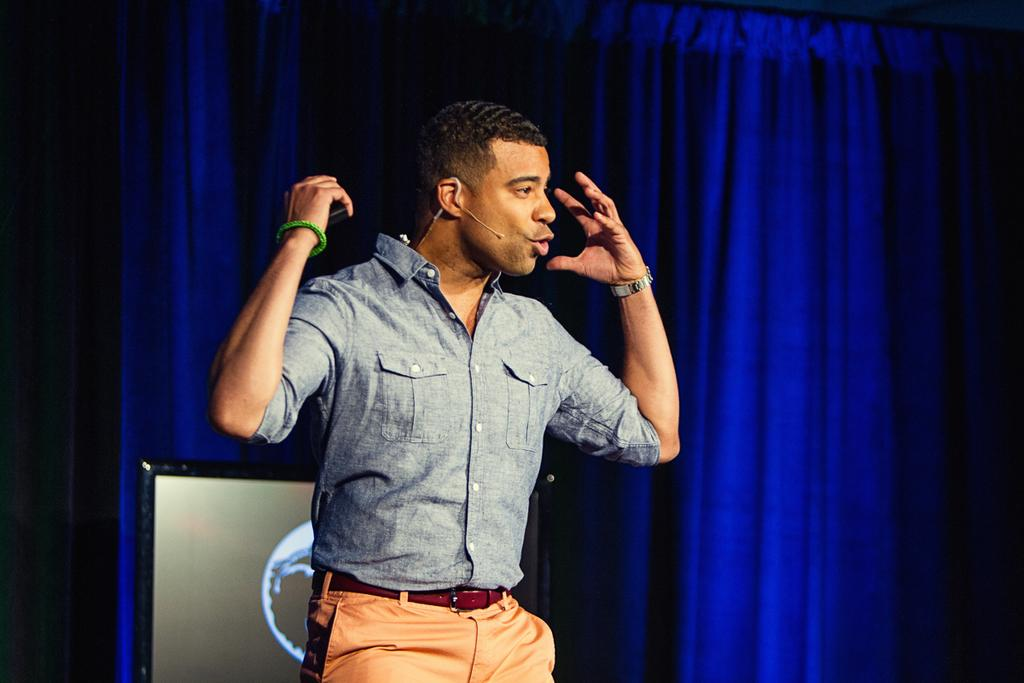What is the man in the image doing? The man is standing in the image. What is the man holding in the image? The man is holding an object. What can be seen on the display screen in the image? The content of the display screen is not specified in the facts. What type of covering is present in the image? There is a curtain in the image. What month is it in the image? The month is not mentioned or depicted in the image. What type of property does the man own in the image? There is no information about the man's property in the image. 